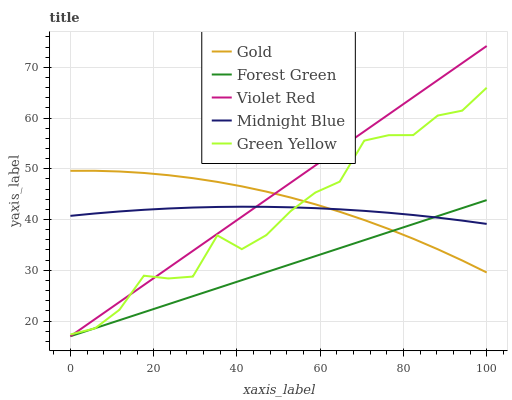Does Forest Green have the minimum area under the curve?
Answer yes or no. Yes. Does Violet Red have the maximum area under the curve?
Answer yes or no. Yes. Does Green Yellow have the minimum area under the curve?
Answer yes or no. No. Does Green Yellow have the maximum area under the curve?
Answer yes or no. No. Is Forest Green the smoothest?
Answer yes or no. Yes. Is Green Yellow the roughest?
Answer yes or no. Yes. Is Violet Red the smoothest?
Answer yes or no. No. Is Violet Red the roughest?
Answer yes or no. No. Does Forest Green have the lowest value?
Answer yes or no. Yes. Does Green Yellow have the lowest value?
Answer yes or no. No. Does Violet Red have the highest value?
Answer yes or no. Yes. Does Green Yellow have the highest value?
Answer yes or no. No. Does Green Yellow intersect Forest Green?
Answer yes or no. Yes. Is Green Yellow less than Forest Green?
Answer yes or no. No. Is Green Yellow greater than Forest Green?
Answer yes or no. No. 